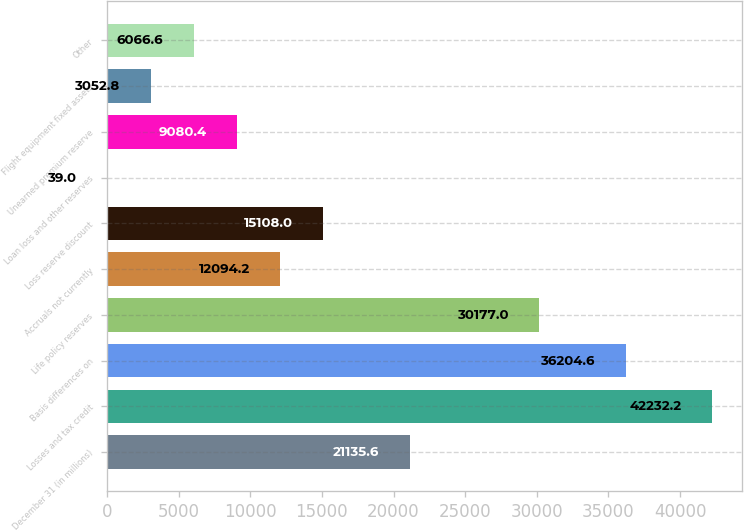Convert chart to OTSL. <chart><loc_0><loc_0><loc_500><loc_500><bar_chart><fcel>December 31 (in millions)<fcel>Losses and tax credit<fcel>Basis differences on<fcel>Life policy reserves<fcel>Accruals not currently<fcel>Loss reserve discount<fcel>Loan loss and other reserves<fcel>Unearned premium reserve<fcel>Flight equipment fixed assets<fcel>Other<nl><fcel>21135.6<fcel>42232.2<fcel>36204.6<fcel>30177<fcel>12094.2<fcel>15108<fcel>39<fcel>9080.4<fcel>3052.8<fcel>6066.6<nl></chart> 